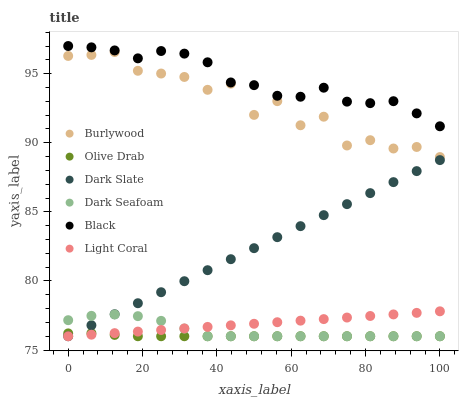Does Olive Drab have the minimum area under the curve?
Answer yes or no. Yes. Does Black have the maximum area under the curve?
Answer yes or no. Yes. Does Light Coral have the minimum area under the curve?
Answer yes or no. No. Does Light Coral have the maximum area under the curve?
Answer yes or no. No. Is Light Coral the smoothest?
Answer yes or no. Yes. Is Burlywood the roughest?
Answer yes or no. Yes. Is Dark Slate the smoothest?
Answer yes or no. No. Is Dark Slate the roughest?
Answer yes or no. No. Does Light Coral have the lowest value?
Answer yes or no. Yes. Does Black have the lowest value?
Answer yes or no. No. Does Black have the highest value?
Answer yes or no. Yes. Does Light Coral have the highest value?
Answer yes or no. No. Is Light Coral less than Burlywood?
Answer yes or no. Yes. Is Black greater than Burlywood?
Answer yes or no. Yes. Does Olive Drab intersect Dark Seafoam?
Answer yes or no. Yes. Is Olive Drab less than Dark Seafoam?
Answer yes or no. No. Is Olive Drab greater than Dark Seafoam?
Answer yes or no. No. Does Light Coral intersect Burlywood?
Answer yes or no. No. 